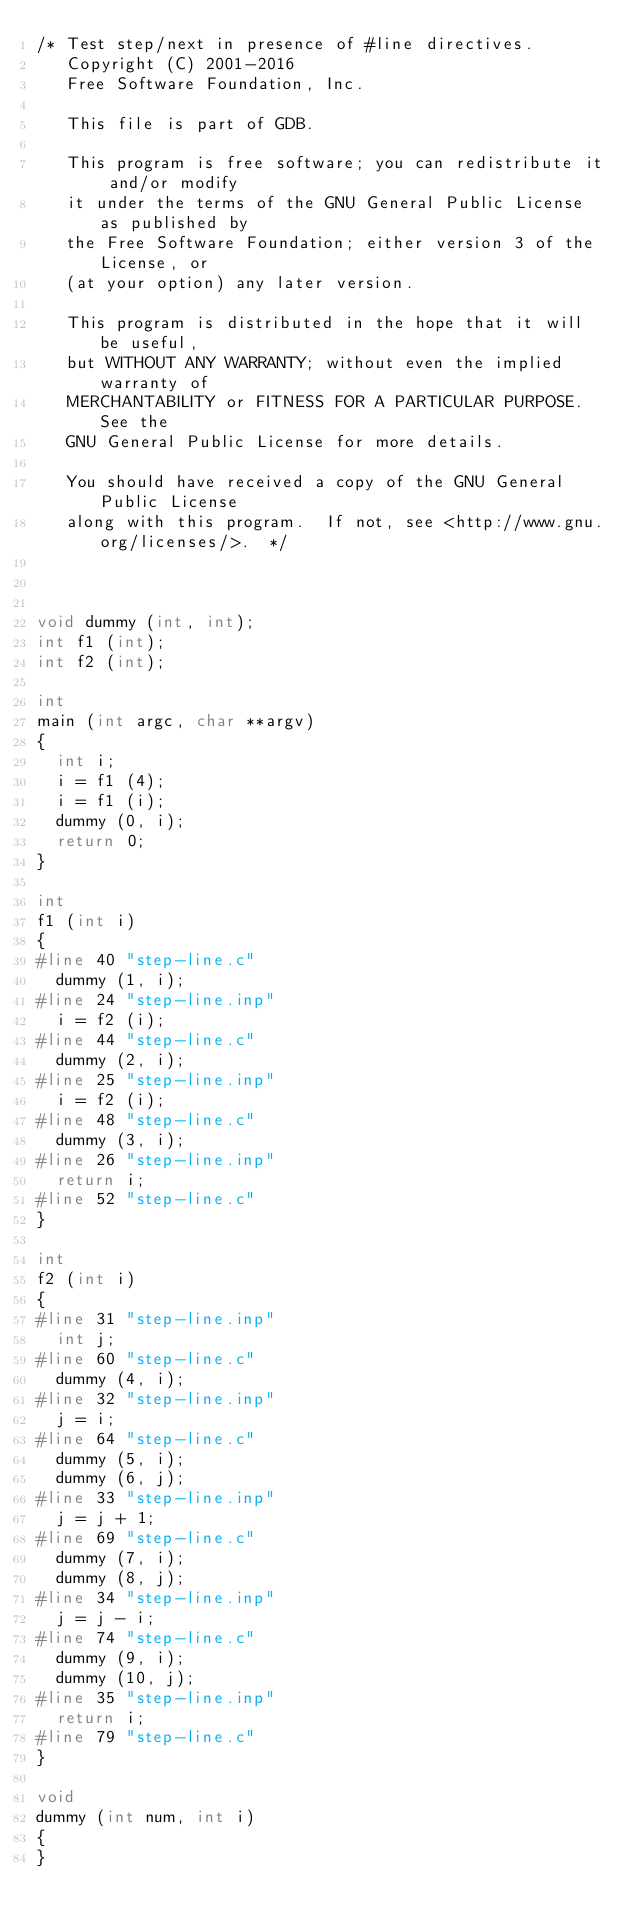Convert code to text. <code><loc_0><loc_0><loc_500><loc_500><_C_>/* Test step/next in presence of #line directives.
   Copyright (C) 2001-2016
   Free Software Foundation, Inc.

   This file is part of GDB.

   This program is free software; you can redistribute it and/or modify
   it under the terms of the GNU General Public License as published by
   the Free Software Foundation; either version 3 of the License, or
   (at your option) any later version.

   This program is distributed in the hope that it will be useful,
   but WITHOUT ANY WARRANTY; without even the implied warranty of
   MERCHANTABILITY or FITNESS FOR A PARTICULAR PURPOSE.  See the
   GNU General Public License for more details.

   You should have received a copy of the GNU General Public License
   along with this program.  If not, see <http://www.gnu.org/licenses/>.  */



void dummy (int, int);
int f1 (int);
int f2 (int);

int
main (int argc, char **argv)
{
  int i;
  i = f1 (4);
  i = f1 (i);
  dummy (0, i);
  return 0;
}

int
f1 (int i)
{
#line 40 "step-line.c"
  dummy (1, i);
#line 24 "step-line.inp"
  i = f2 (i);
#line 44 "step-line.c"
  dummy (2, i);
#line 25 "step-line.inp"
  i = f2 (i);
#line 48 "step-line.c"
  dummy (3, i);
#line 26 "step-line.inp"
  return i;
#line 52 "step-line.c"
}

int
f2 (int i)
{
#line 31 "step-line.inp"
  int j;
#line 60 "step-line.c"
  dummy (4, i);
#line 32 "step-line.inp"
  j = i;
#line 64 "step-line.c"
  dummy (5, i);
  dummy (6, j);
#line 33 "step-line.inp"
  j = j + 1;
#line 69 "step-line.c"
  dummy (7, i);
  dummy (8, j);
#line 34 "step-line.inp"
  j = j - i;
#line 74 "step-line.c"
  dummy (9, i);
  dummy (10, j);
#line 35 "step-line.inp"
  return i;
#line 79 "step-line.c"
}

void
dummy (int num, int i)
{
}
</code> 